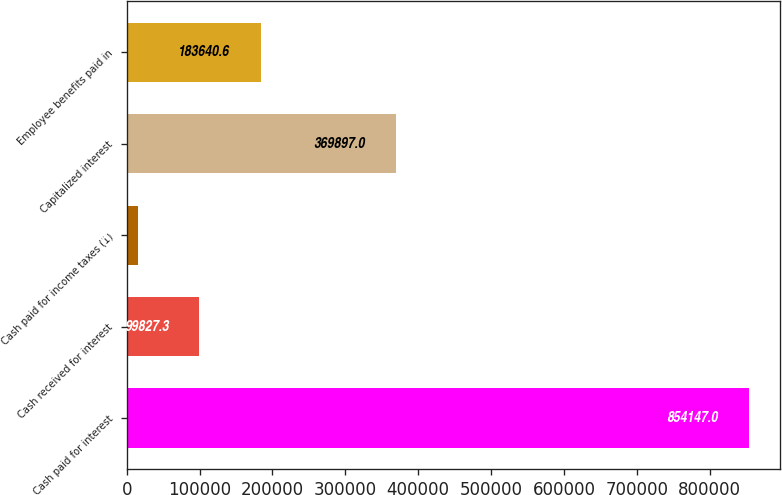Convert chart. <chart><loc_0><loc_0><loc_500><loc_500><bar_chart><fcel>Cash paid for interest<fcel>Cash received for interest<fcel>Cash paid for income taxes (1)<fcel>Capitalized interest<fcel>Employee benefits paid in<nl><fcel>854147<fcel>99827.3<fcel>16014<fcel>369897<fcel>183641<nl></chart> 